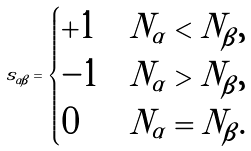<formula> <loc_0><loc_0><loc_500><loc_500>s _ { \alpha \beta } = \begin{cases} + 1 & N _ { \alpha } < N _ { \beta } , \\ - 1 & N _ { \alpha } > N _ { \beta } , \\ 0 & N _ { \alpha } = N _ { \beta } . \end{cases}</formula> 